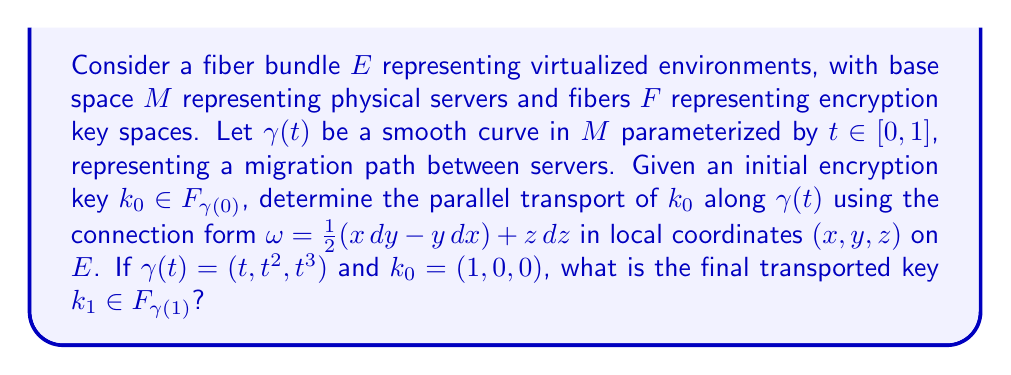Provide a solution to this math problem. To solve this problem, we need to follow these steps:

1) The parallel transport equation for a vector $k(t) = (k_1(t), k_2(t), k_3(t))$ along $\gamma(t)$ is given by:

   $$\frac{dk}{dt} + \omega(\gamma'(t))k = 0$$

2) We need to calculate $\omega(\gamma'(t))$:
   
   $\gamma(t) = (t, t^2, t^3)$, so $\gamma'(t) = (1, 2t, 3t^2)$
   
   $$\omega(\gamma'(t)) = \frac{1}{2}(t \cdot 2t - t^2 \cdot 1) + t^3 \cdot 3t^2 = 3t^5$$

3) Now our parallel transport equation becomes:

   $$\frac{dk}{dt} + 3t^5k = 0$$

4) This is a linear first-order ODE. The general solution is:

   $$k(t) = C \exp(-\int 3t^5 dt) = C \exp(-\frac{1}{2}t^6)$$

   where $C$ is a constant vector determined by the initial condition.

5) Using the initial condition $k_0 = (1,0,0)$ at $t=0$, we get:

   $$k(t) = (1,0,0) \exp(-\frac{1}{2}t^6)$$

6) The final transported key $k_1$ is $k(1)$:

   $$k_1 = k(1) = (1,0,0) \exp(-\frac{1}{2})$$

7) Calculating the exponential:

   $$\exp(-\frac{1}{2}) \approx 0.6065$$

Therefore, the final transported key is approximately $(0.6065, 0, 0)$.
Answer: The final transported key $k_1 \in F_{\gamma(1)}$ is approximately $(0.6065, 0, 0)$. 